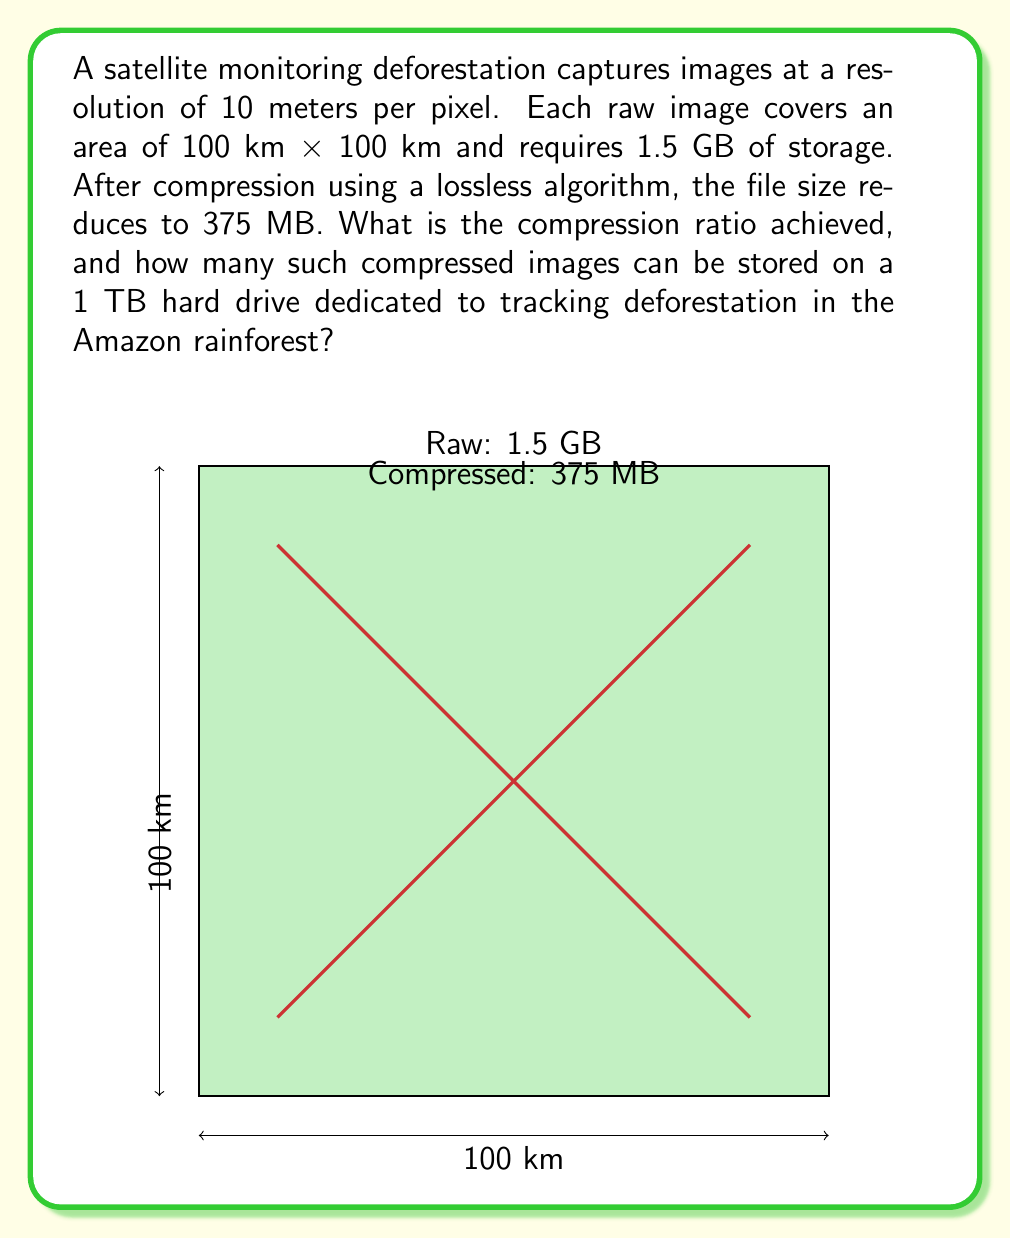Can you solve this math problem? Let's approach this problem step-by-step:

1. Calculate the compression ratio:
   Compression ratio = Original size / Compressed size
   $$ \text{Compression ratio} = \frac{1.5 \text{ GB}}{375 \text{ MB}} $$
   
   First, convert GB to MB:
   $$ 1.5 \text{ GB} = 1.5 \times 1024 \text{ MB} = 1536 \text{ MB} $$
   
   Now calculate the ratio:
   $$ \text{Compression ratio} = \frac{1536 \text{ MB}}{375 \text{ MB}} = 4.096 $$

2. To find how many compressed images can be stored on a 1 TB drive:
   First, convert 1 TB to MB:
   $$ 1 \text{ TB} = 1024 \text{ GB} = 1024 \times 1024 \text{ MB} = 1,048,576 \text{ MB} $$
   
   Now divide the total storage by the size of one compressed image:
   $$ \text{Number of images} = \frac{1,048,576 \text{ MB}}{375 \text{ MB per image}} = 2,796.2 $$

   Since we can't store partial images, we round down to 2,796 images.

3. Calculate the total area that can be monitored:
   Each image covers 100 km x 100 km = 10,000 km²
   Total area = 2,796 × 10,000 km² = 27,960,000 km²

This amount of data allows for extensive monitoring of the Amazon rainforest, which covers approximately 5.5 million km², highlighting the efficiency of compression in environmental monitoring efforts.
Answer: Compression ratio: 4.096:1; Images stored: 2,796 